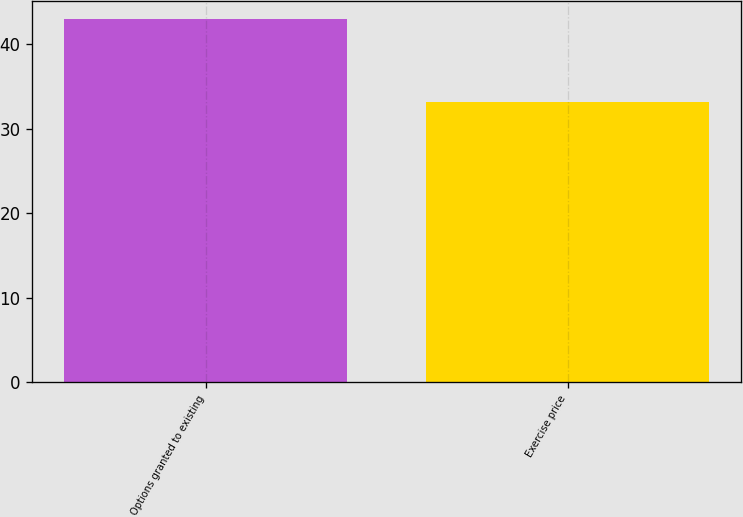Convert chart. <chart><loc_0><loc_0><loc_500><loc_500><bar_chart><fcel>Options granted to existing<fcel>Exercise price<nl><fcel>43<fcel>33.18<nl></chart> 